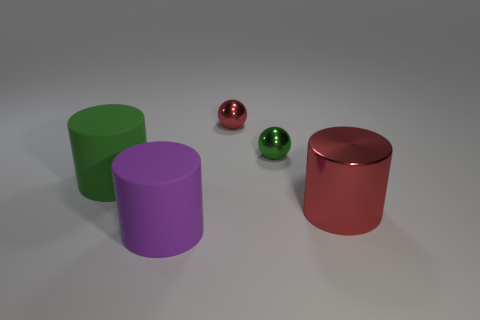Are there any other things that have the same material as the big green thing?
Offer a very short reply. Yes. There is a big purple object that is the same shape as the big green thing; what is it made of?
Provide a succinct answer. Rubber. What number of big things are green cylinders or red spheres?
Keep it short and to the point. 1. Are there fewer cylinders right of the red cylinder than large purple rubber things that are behind the tiny green ball?
Your answer should be compact. No. How many things are small red shiny objects or big yellow metal spheres?
Offer a very short reply. 1. There is a tiny red shiny ball; what number of big rubber objects are on the left side of it?
Offer a very short reply. 2. There is a green thing that is made of the same material as the purple cylinder; what is its shape?
Your answer should be very brief. Cylinder. There is a red object in front of the large green cylinder; does it have the same shape as the green matte thing?
Provide a short and direct response. Yes. What number of cyan things are either cylinders or big metallic cylinders?
Your response must be concise. 0. Are there an equal number of red objects to the left of the big red cylinder and big cylinders in front of the green cylinder?
Ensure brevity in your answer.  No. 